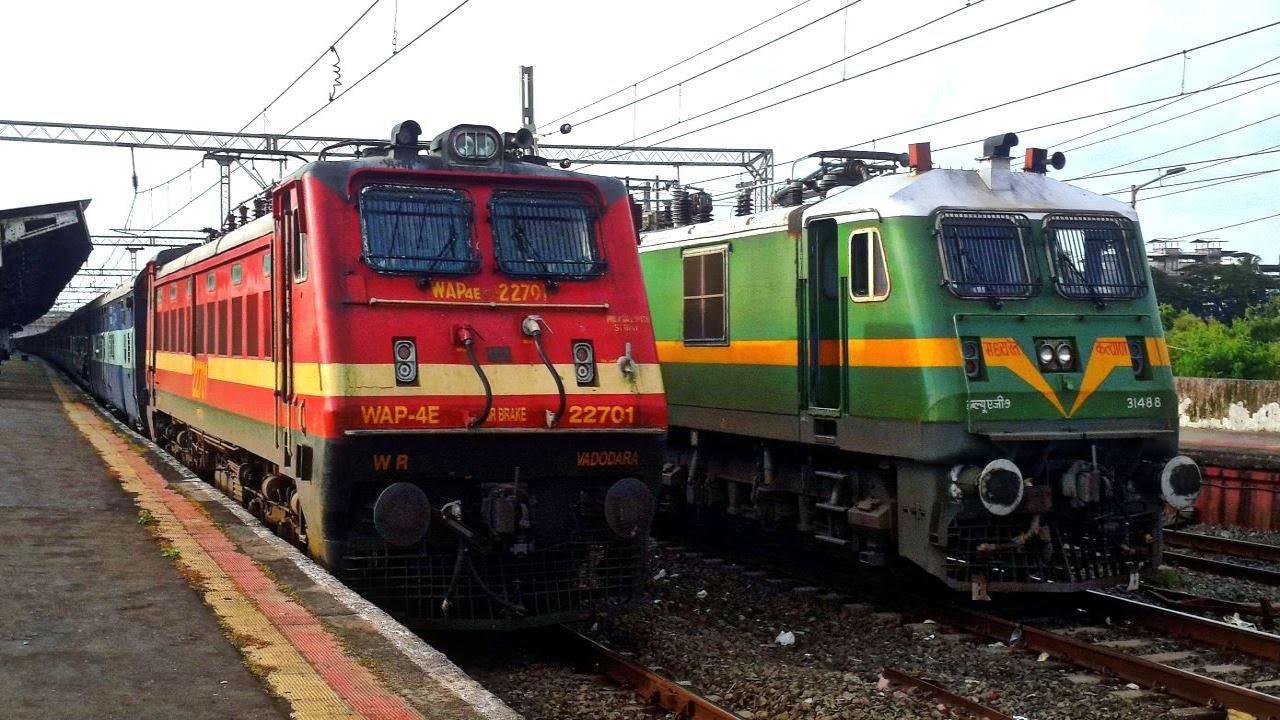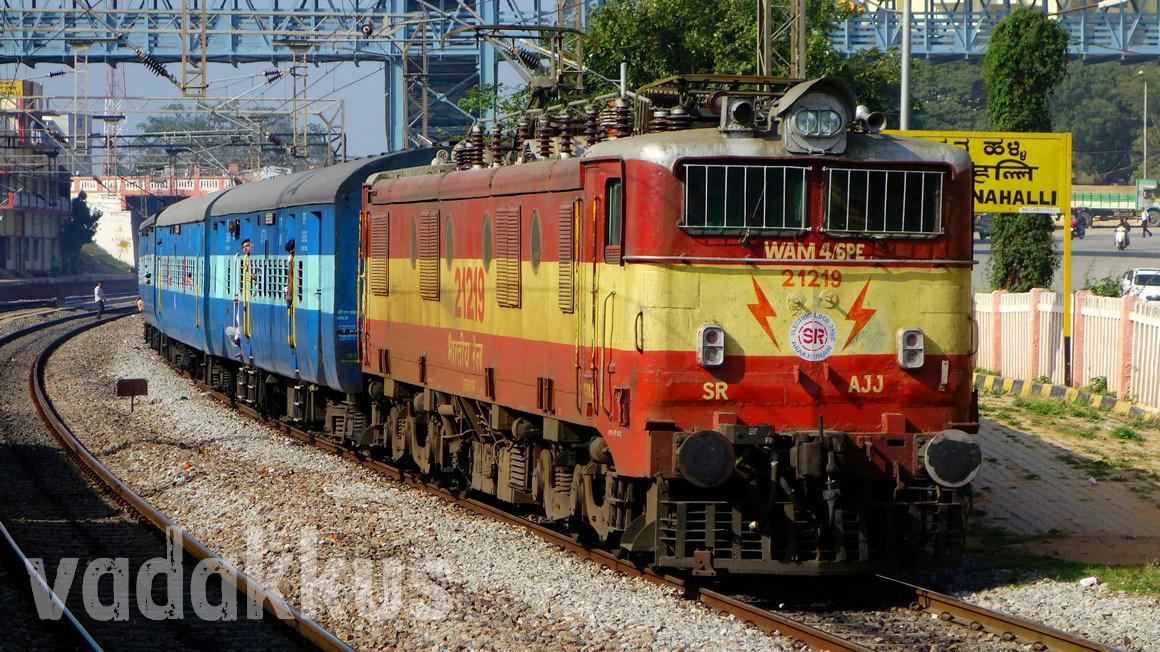The first image is the image on the left, the second image is the image on the right. Considering the images on both sides, is "The left image includes a train that is reddish-orange with a yellow horizontal stripe." valid? Answer yes or no. Yes. 